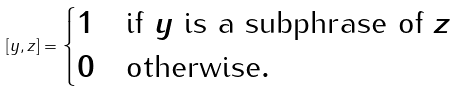Convert formula to latex. <formula><loc_0><loc_0><loc_500><loc_500>[ y , z ] = \begin{cases} 1 & \text {if $y$ is a subphrase of $z$} \\ 0 & \text {otherwise} . \end{cases}</formula> 